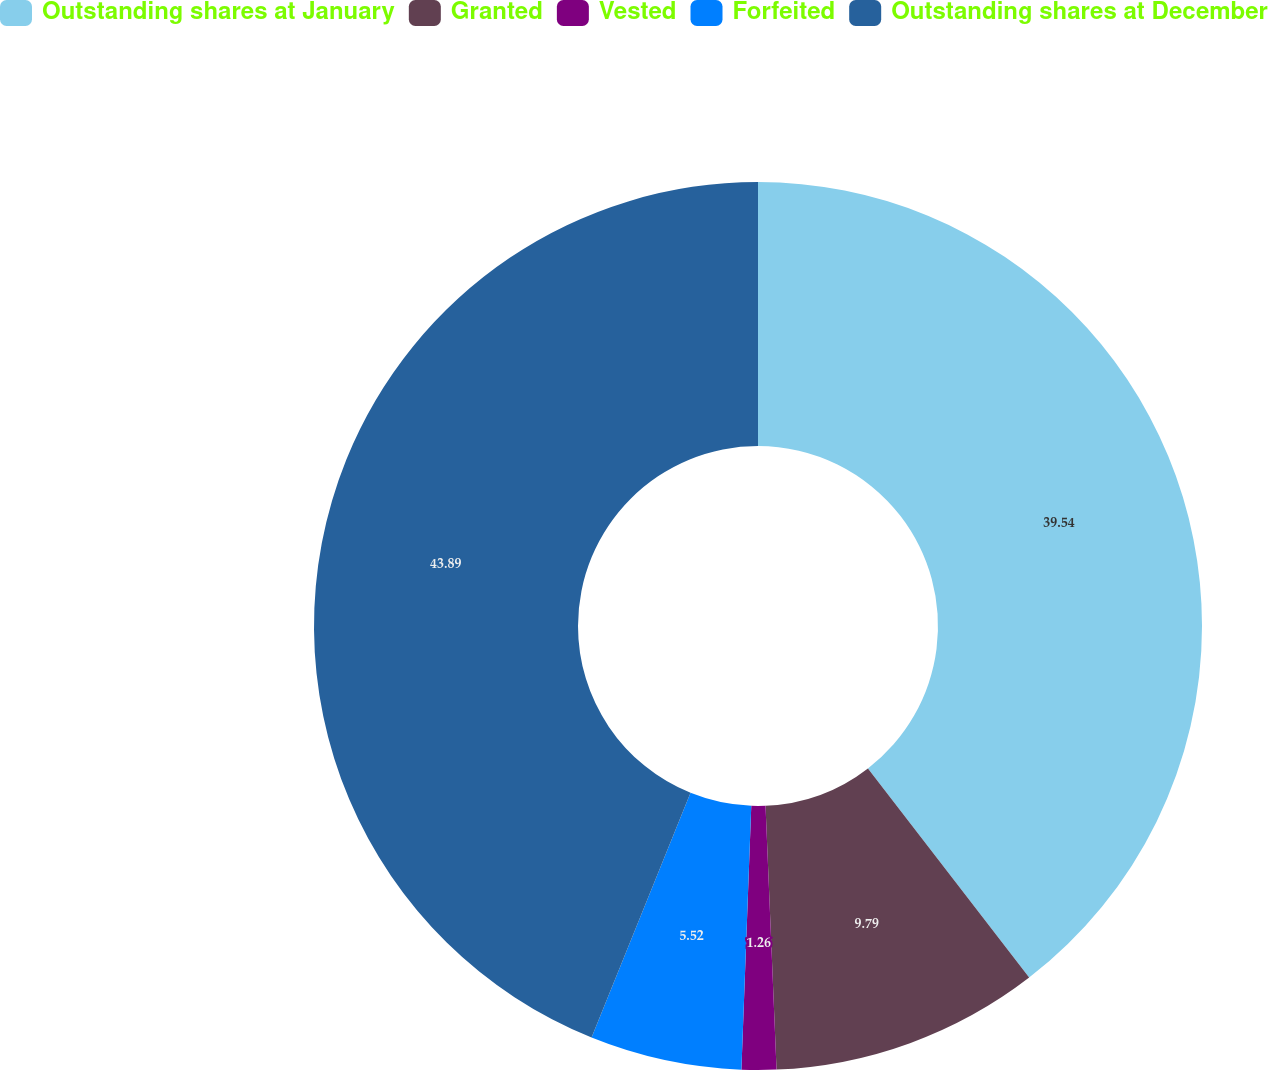Convert chart. <chart><loc_0><loc_0><loc_500><loc_500><pie_chart><fcel>Outstanding shares at January<fcel>Granted<fcel>Vested<fcel>Forfeited<fcel>Outstanding shares at December<nl><fcel>39.54%<fcel>9.79%<fcel>1.26%<fcel>5.52%<fcel>43.88%<nl></chart> 